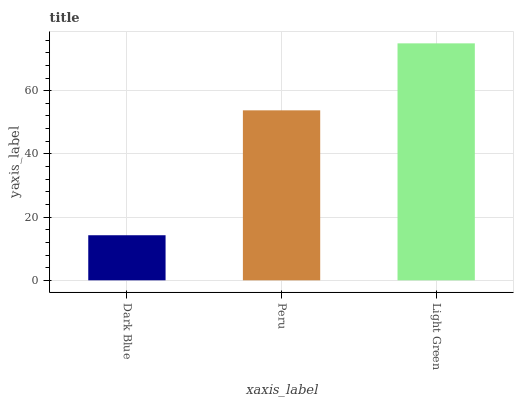Is Dark Blue the minimum?
Answer yes or no. Yes. Is Light Green the maximum?
Answer yes or no. Yes. Is Peru the minimum?
Answer yes or no. No. Is Peru the maximum?
Answer yes or no. No. Is Peru greater than Dark Blue?
Answer yes or no. Yes. Is Dark Blue less than Peru?
Answer yes or no. Yes. Is Dark Blue greater than Peru?
Answer yes or no. No. Is Peru less than Dark Blue?
Answer yes or no. No. Is Peru the high median?
Answer yes or no. Yes. Is Peru the low median?
Answer yes or no. Yes. Is Light Green the high median?
Answer yes or no. No. Is Dark Blue the low median?
Answer yes or no. No. 